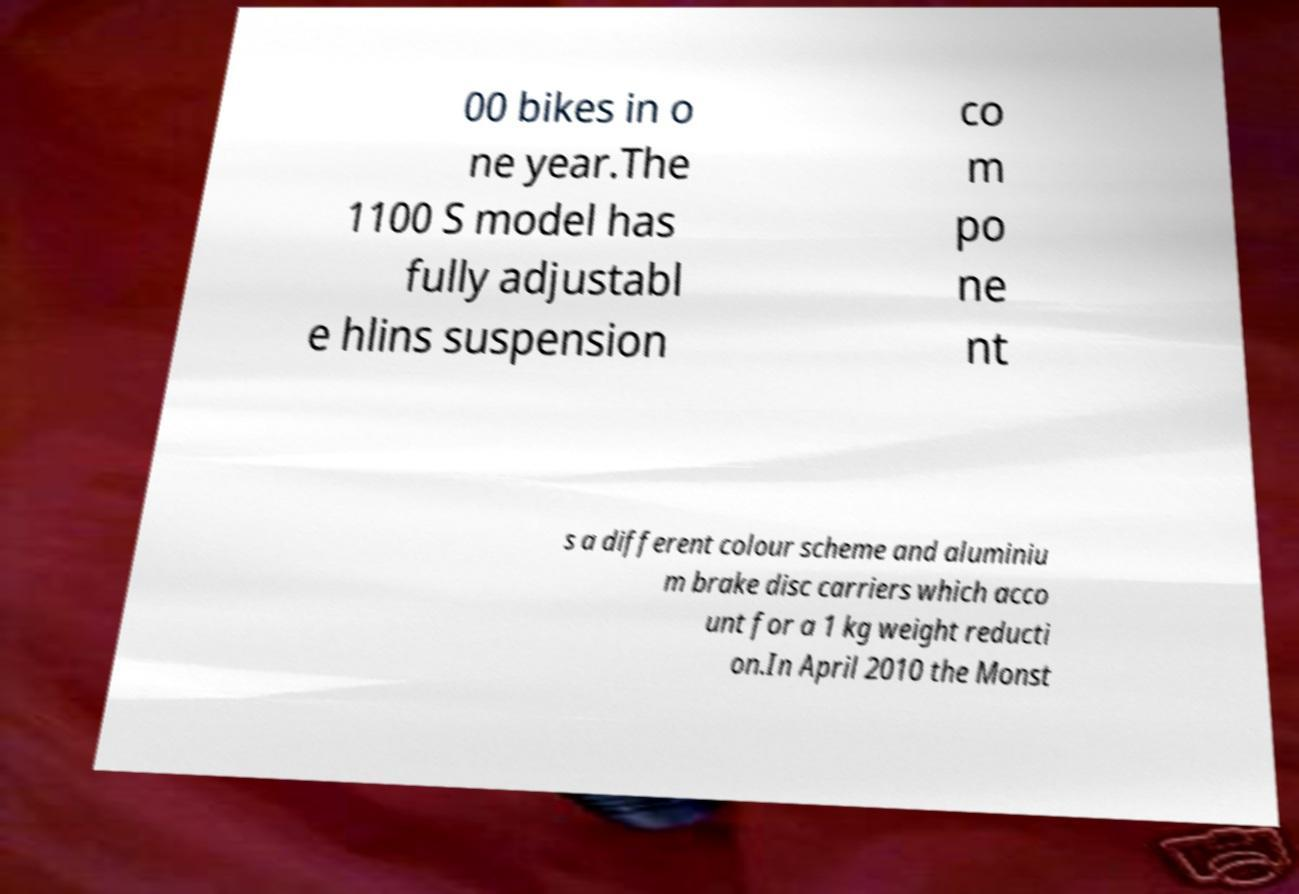Please identify and transcribe the text found in this image. 00 bikes in o ne year.The 1100 S model has fully adjustabl e hlins suspension co m po ne nt s a different colour scheme and aluminiu m brake disc carriers which acco unt for a 1 kg weight reducti on.In April 2010 the Monst 